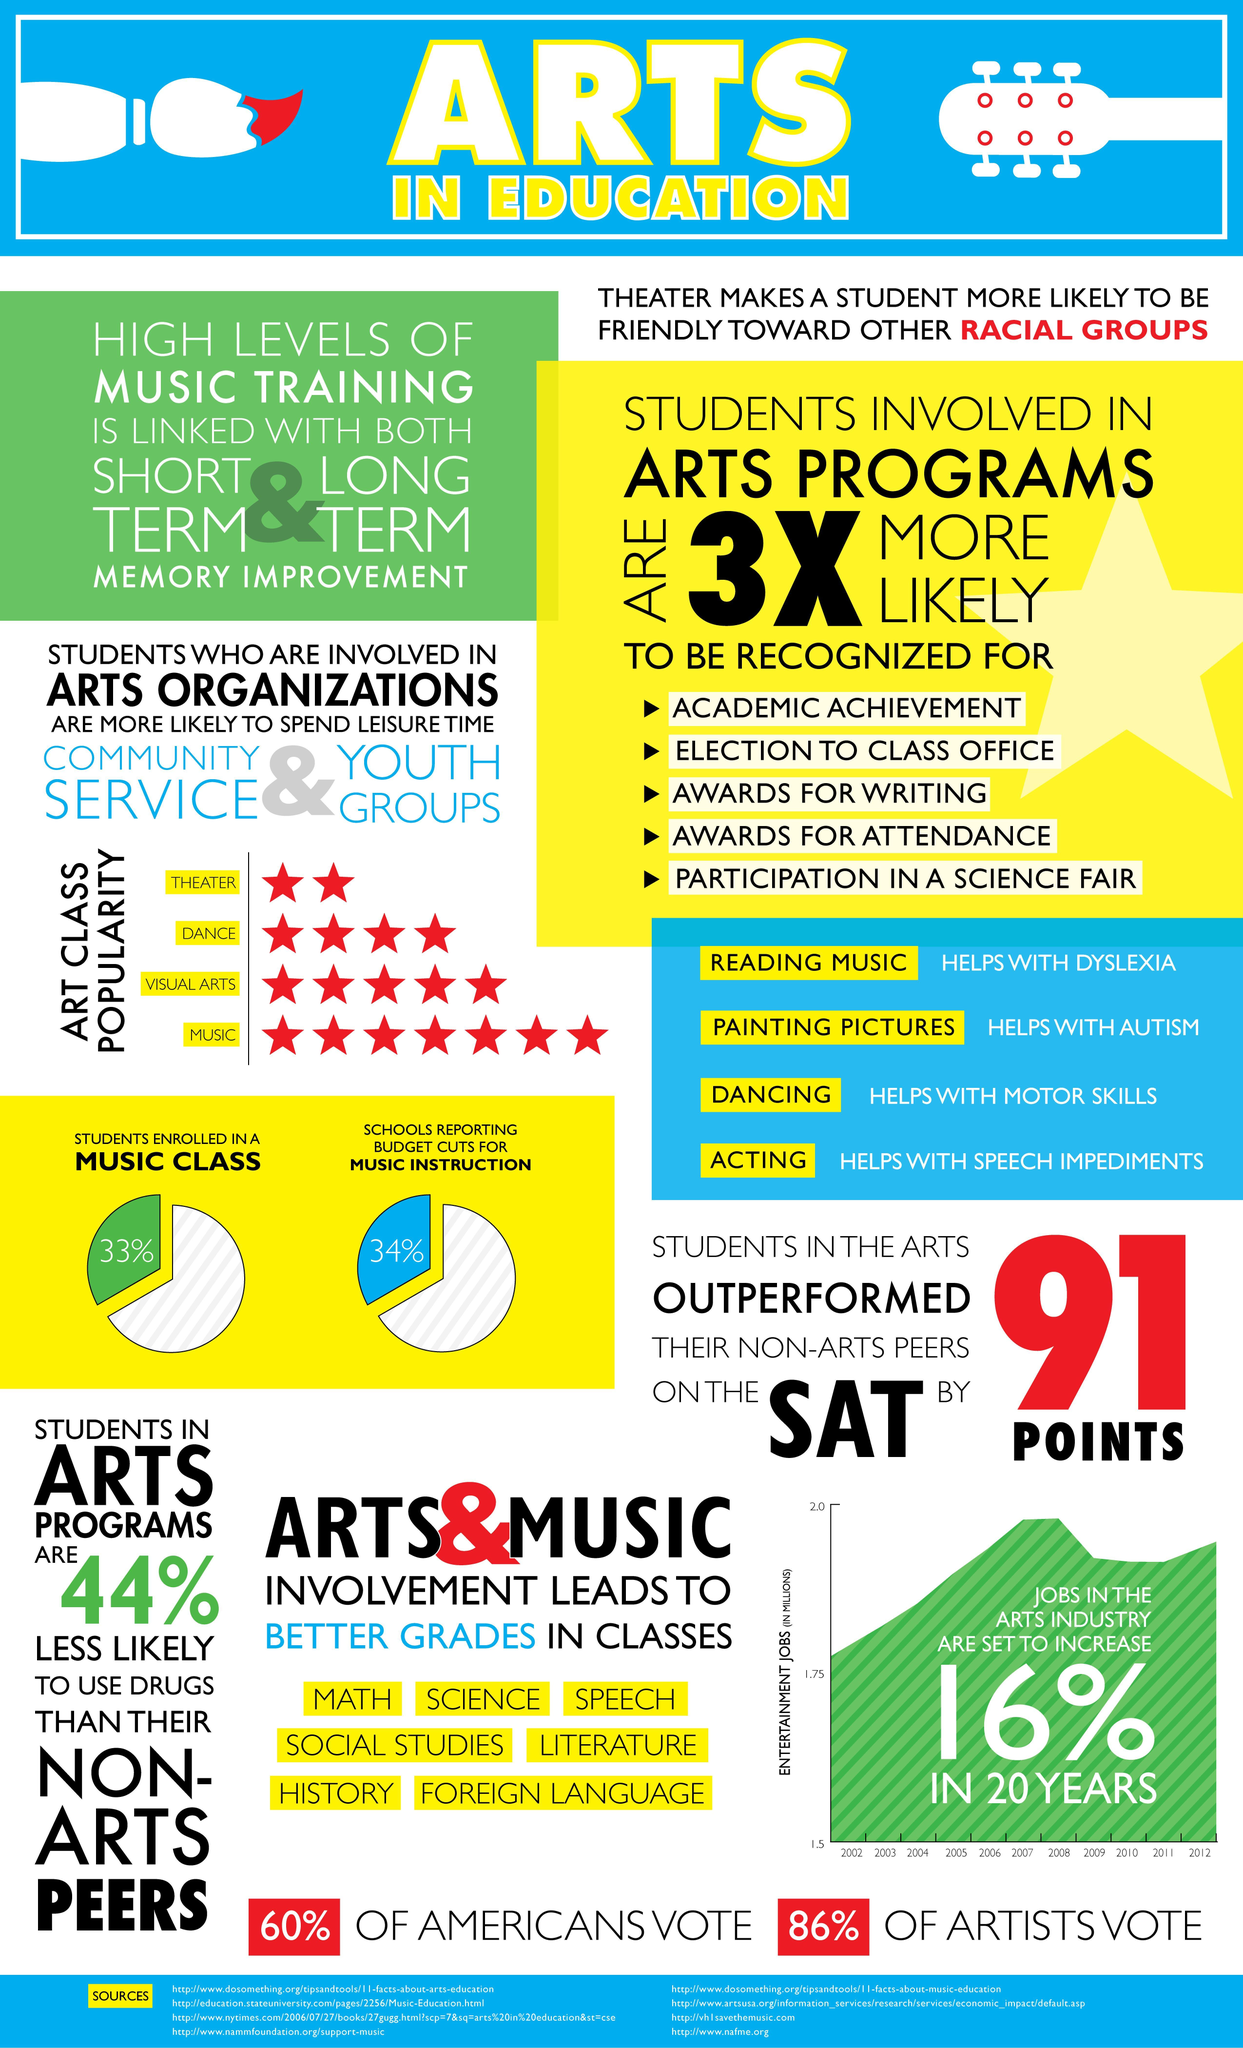What percentage of jobs in the arts industry are set to increase in 20 years?
Answer the question with a short phrase. 16% What percentage of students are not enrolled in a music class? 67% 